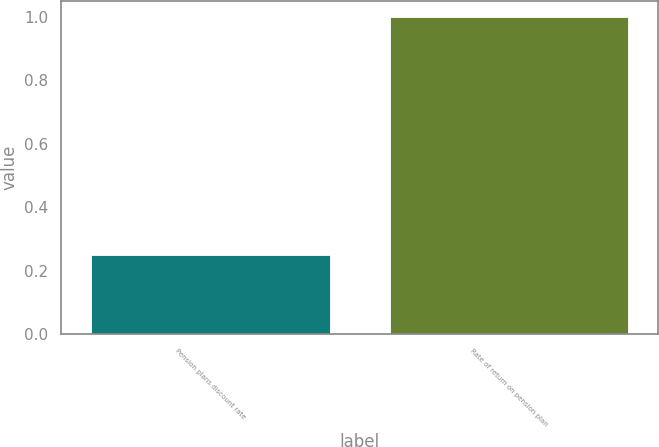Convert chart to OTSL. <chart><loc_0><loc_0><loc_500><loc_500><bar_chart><fcel>Pension plans discount rate<fcel>Rate of return on pension plan<nl><fcel>0.25<fcel>1<nl></chart> 